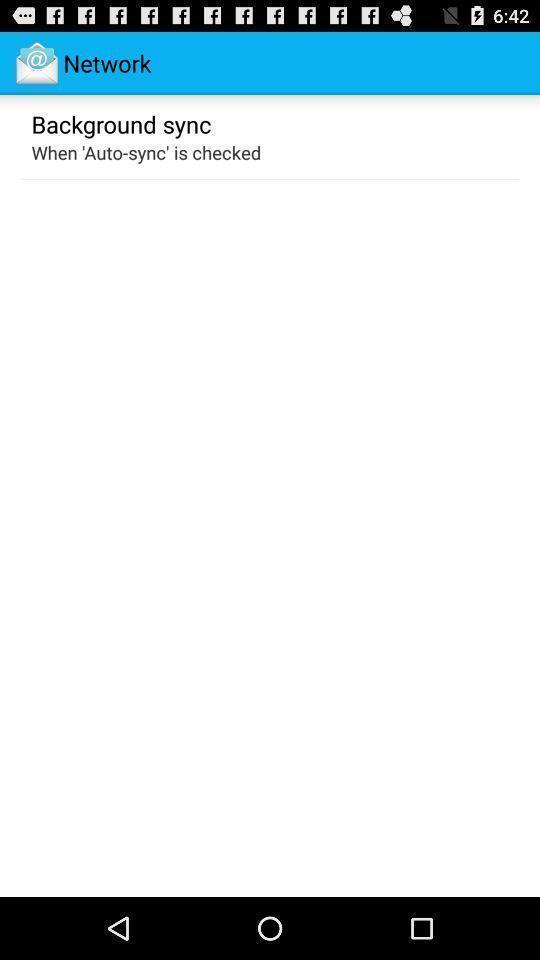Describe this image in words. Page showing information about application. 